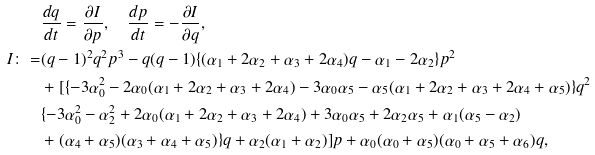Convert formula to latex. <formula><loc_0><loc_0><loc_500><loc_500>& \frac { d q } { d t } = \frac { \partial I } { \partial p } , \quad \frac { d p } { d t } = - \frac { \partial I } { \partial q } , \\ I \colon = & ( q - 1 ) ^ { 2 } q ^ { 2 } p ^ { 3 } - q ( q - 1 ) \{ ( \alpha _ { 1 } + 2 \alpha _ { 2 } + \alpha _ { 3 } + 2 \alpha _ { 4 } ) q - \alpha _ { 1 } - 2 \alpha _ { 2 } \} p ^ { 2 } \\ & + [ \{ - 3 \alpha _ { 0 } ^ { 2 } - 2 \alpha _ { 0 } ( \alpha _ { 1 } + 2 \alpha _ { 2 } + \alpha _ { 3 } + 2 \alpha _ { 4 } ) - 3 \alpha _ { 0 } \alpha _ { 5 } - \alpha _ { 5 } ( \alpha _ { 1 } + 2 \alpha _ { 2 } + \alpha _ { 3 } + 2 \alpha _ { 4 } + \alpha _ { 5 } ) \} q ^ { 2 } \\ & \{ - 3 \alpha _ { 0 } ^ { 2 } - \alpha _ { 2 } ^ { 2 } + 2 \alpha _ { 0 } ( \alpha _ { 1 } + 2 \alpha _ { 2 } + \alpha _ { 3 } + 2 \alpha _ { 4 } ) + 3 \alpha _ { 0 } \alpha _ { 5 } + 2 \alpha _ { 2 } \alpha _ { 5 } + \alpha _ { 1 } ( \alpha _ { 5 } - \alpha _ { 2 } ) \\ & + ( \alpha _ { 4 } + \alpha _ { 5 } ) ( \alpha _ { 3 } + \alpha _ { 4 } + \alpha _ { 5 } ) \} q + \alpha _ { 2 } ( \alpha _ { 1 } + \alpha _ { 2 } ) ] p + \alpha _ { 0 } ( \alpha _ { 0 } + \alpha _ { 5 } ) ( \alpha _ { 0 } + \alpha _ { 5 } + \alpha _ { 6 } ) q ,</formula> 